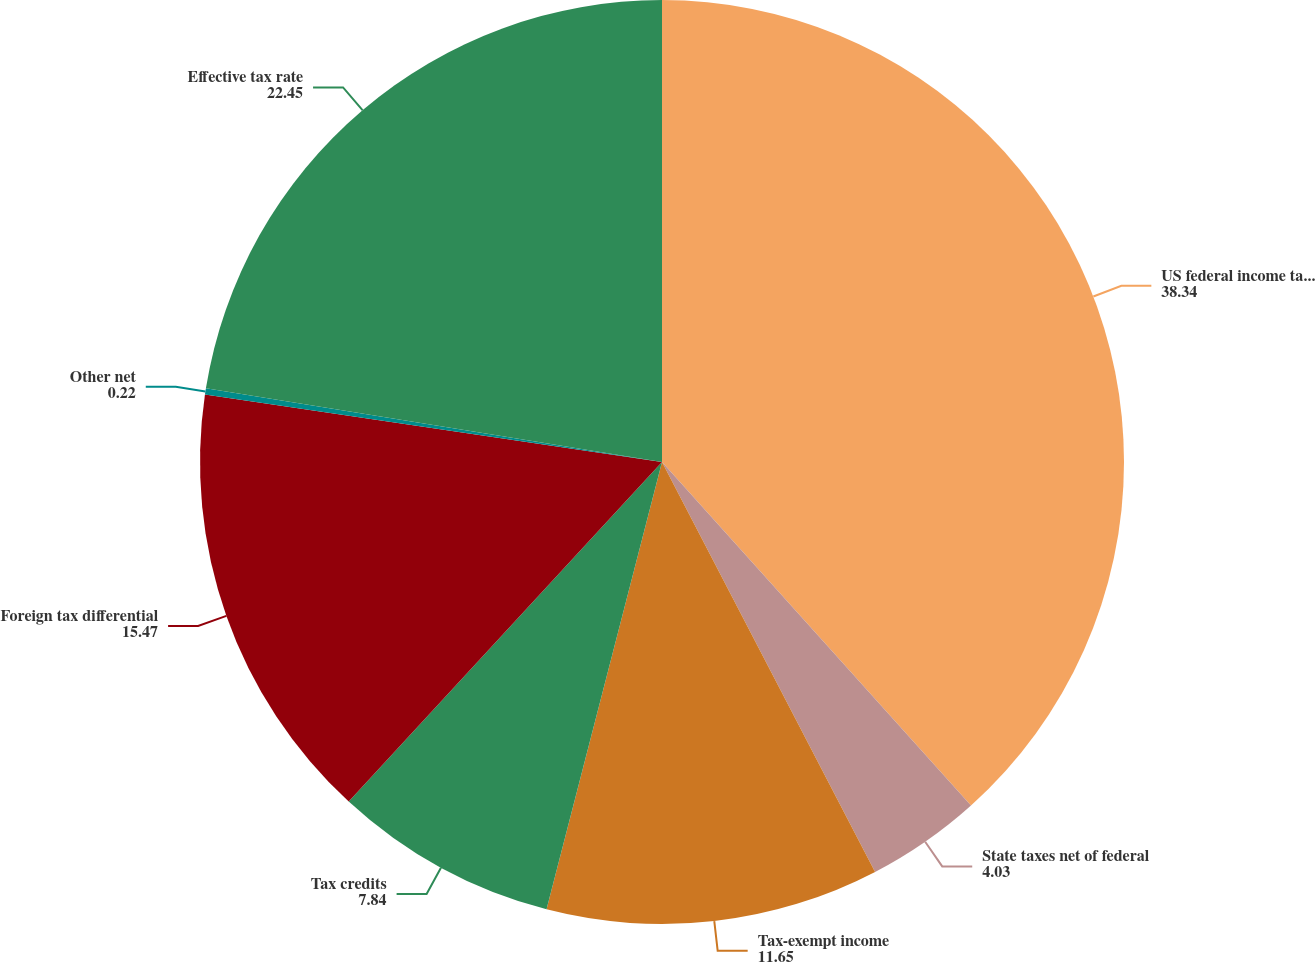<chart> <loc_0><loc_0><loc_500><loc_500><pie_chart><fcel>US federal income tax rate<fcel>State taxes net of federal<fcel>Tax-exempt income<fcel>Tax credits<fcel>Foreign tax differential<fcel>Other net<fcel>Effective tax rate<nl><fcel>38.34%<fcel>4.03%<fcel>11.65%<fcel>7.84%<fcel>15.47%<fcel>0.22%<fcel>22.45%<nl></chart> 